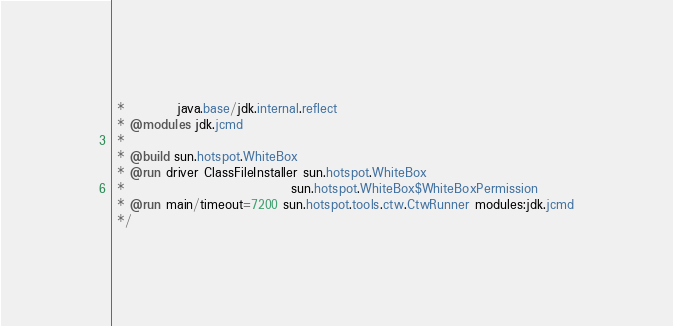<code> <loc_0><loc_0><loc_500><loc_500><_Java_> *          java.base/jdk.internal.reflect
 * @modules jdk.jcmd
 *
 * @build sun.hotspot.WhiteBox
 * @run driver ClassFileInstaller sun.hotspot.WhiteBox
 *                                sun.hotspot.WhiteBox$WhiteBoxPermission
 * @run main/timeout=7200 sun.hotspot.tools.ctw.CtwRunner modules:jdk.jcmd
 */
</code> 